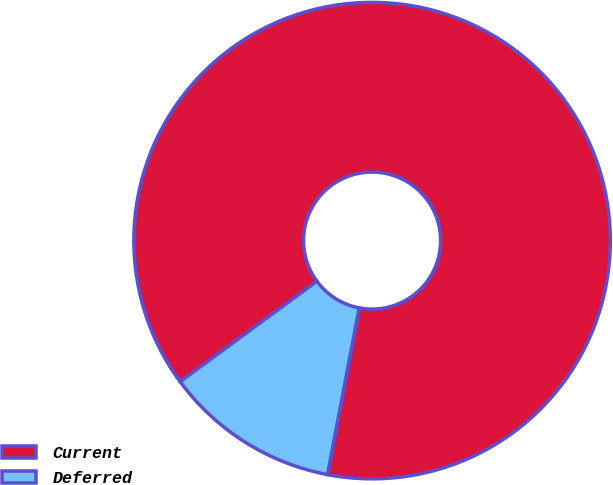<chart> <loc_0><loc_0><loc_500><loc_500><pie_chart><fcel>Current<fcel>Deferred<nl><fcel>88.08%<fcel>11.92%<nl></chart> 